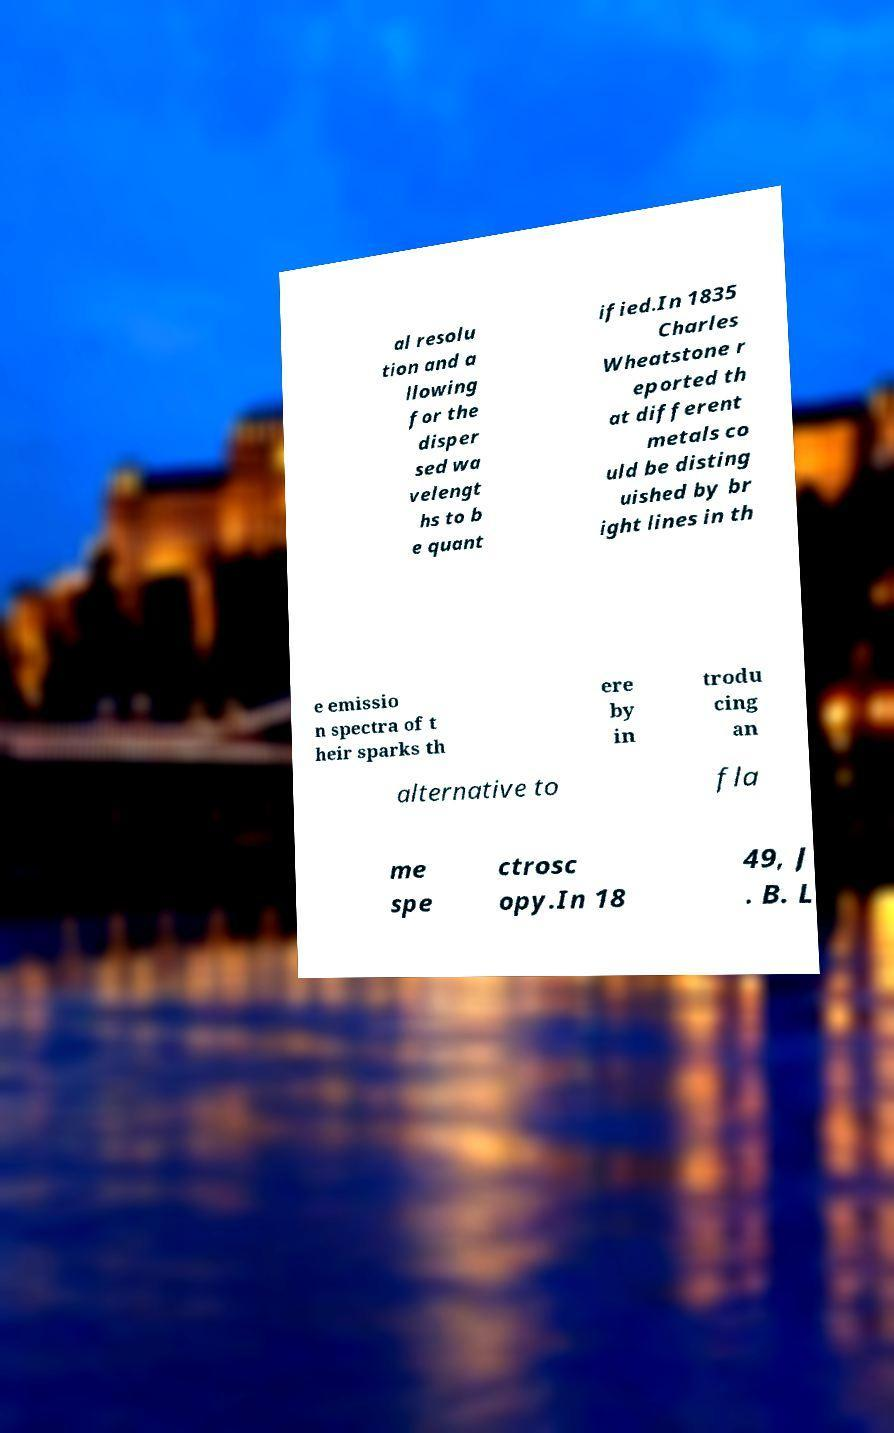Could you assist in decoding the text presented in this image and type it out clearly? al resolu tion and a llowing for the disper sed wa velengt hs to b e quant ified.In 1835 Charles Wheatstone r eported th at different metals co uld be disting uished by br ight lines in th e emissio n spectra of t heir sparks th ere by in trodu cing an alternative to fla me spe ctrosc opy.In 18 49, J . B. L 